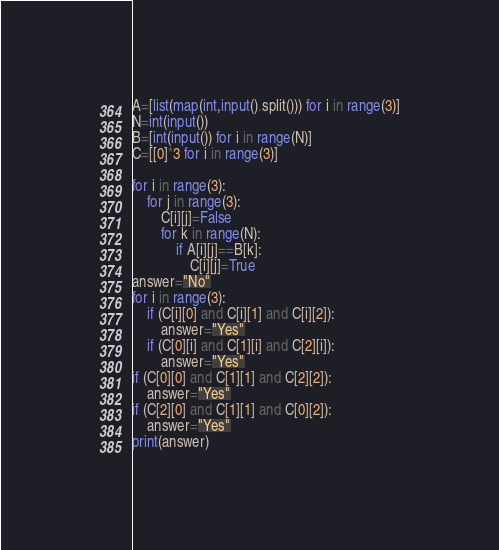<code> <loc_0><loc_0><loc_500><loc_500><_Python_>A=[list(map(int,input().split())) for i in range(3)]
N=int(input())
B=[int(input()) for i in range(N)]
C=[[0]*3 for i in range(3)]

for i in range(3):
	for j in range(3):
		C[i][j]=False
		for k in range(N):
			if A[i][j]==B[k]:
				C[i][j]=True
answer="No"
for i in range(3):
	if (C[i][0] and C[i][1] and C[i][2]):
		answer="Yes"
	if (C[0][i] and C[1][i] and C[2][i]):
		answer="Yes"
if (C[0][0] and C[1][1] and C[2][2]):
	answer="Yes"
if (C[2][0] and C[1][1] and C[0][2]):
	answer="Yes"
print(answer)</code> 